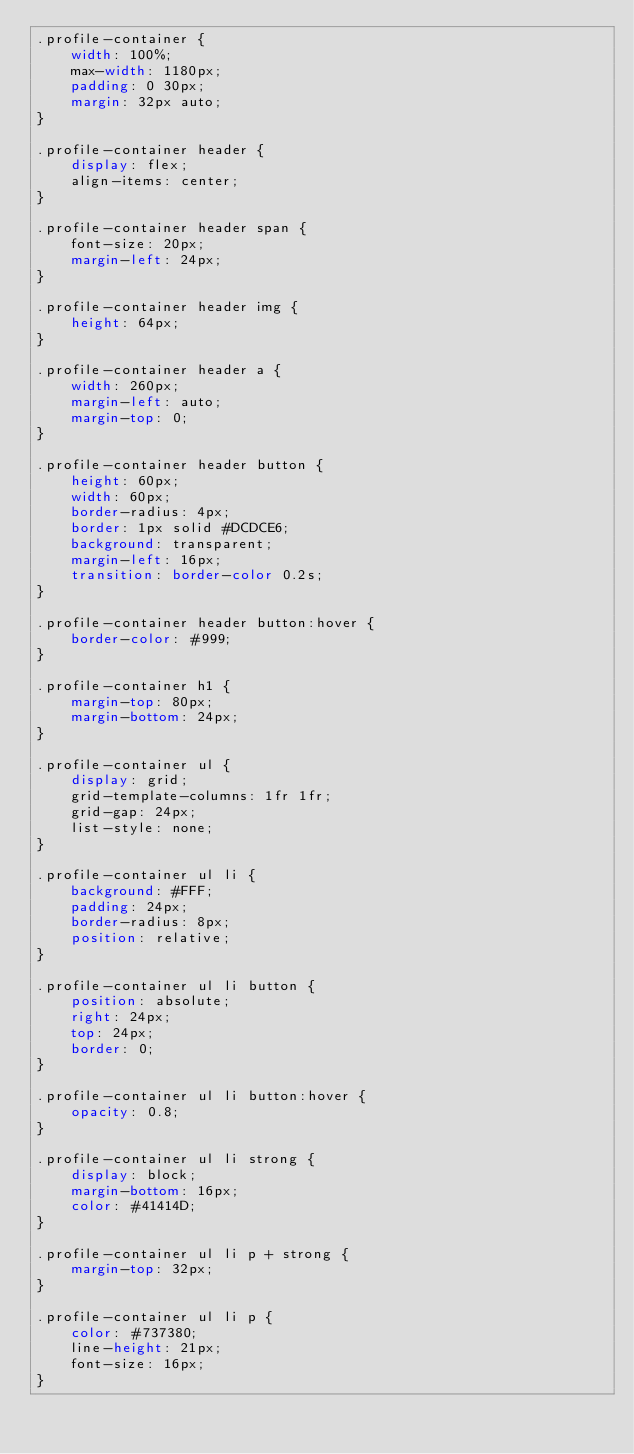Convert code to text. <code><loc_0><loc_0><loc_500><loc_500><_CSS_>.profile-container {
    width: 100%;
    max-width: 1180px;
    padding: 0 30px;
    margin: 32px auto;
}

.profile-container header {
    display: flex;
    align-items: center;
}

.profile-container header span {
    font-size: 20px;
    margin-left: 24px;
}

.profile-container header img {
    height: 64px;
}

.profile-container header a {
    width: 260px;
    margin-left: auto;
    margin-top: 0;
}

.profile-container header button {
    height: 60px;
    width: 60px;
    border-radius: 4px;
    border: 1px solid #DCDCE6;
    background: transparent;
    margin-left: 16px;
    transition: border-color 0.2s;
}

.profile-container header button:hover {
    border-color: #999;
}

.profile-container h1 {
    margin-top: 80px;
    margin-bottom: 24px;
}

.profile-container ul {
    display: grid;
    grid-template-columns: 1fr 1fr;
    grid-gap: 24px;
    list-style: none;
}

.profile-container ul li {
    background: #FFF;
    padding: 24px;
    border-radius: 8px;
    position: relative;
}

.profile-container ul li button {
    position: absolute;
    right: 24px;
    top: 24px;
    border: 0;
}

.profile-container ul li button:hover {
    opacity: 0.8;
}

.profile-container ul li strong {
    display: block;
    margin-bottom: 16px;
    color: #41414D;
}

.profile-container ul li p + strong {
    margin-top: 32px;
}

.profile-container ul li p {
    color: #737380;
    line-height: 21px;
    font-size: 16px;
}</code> 